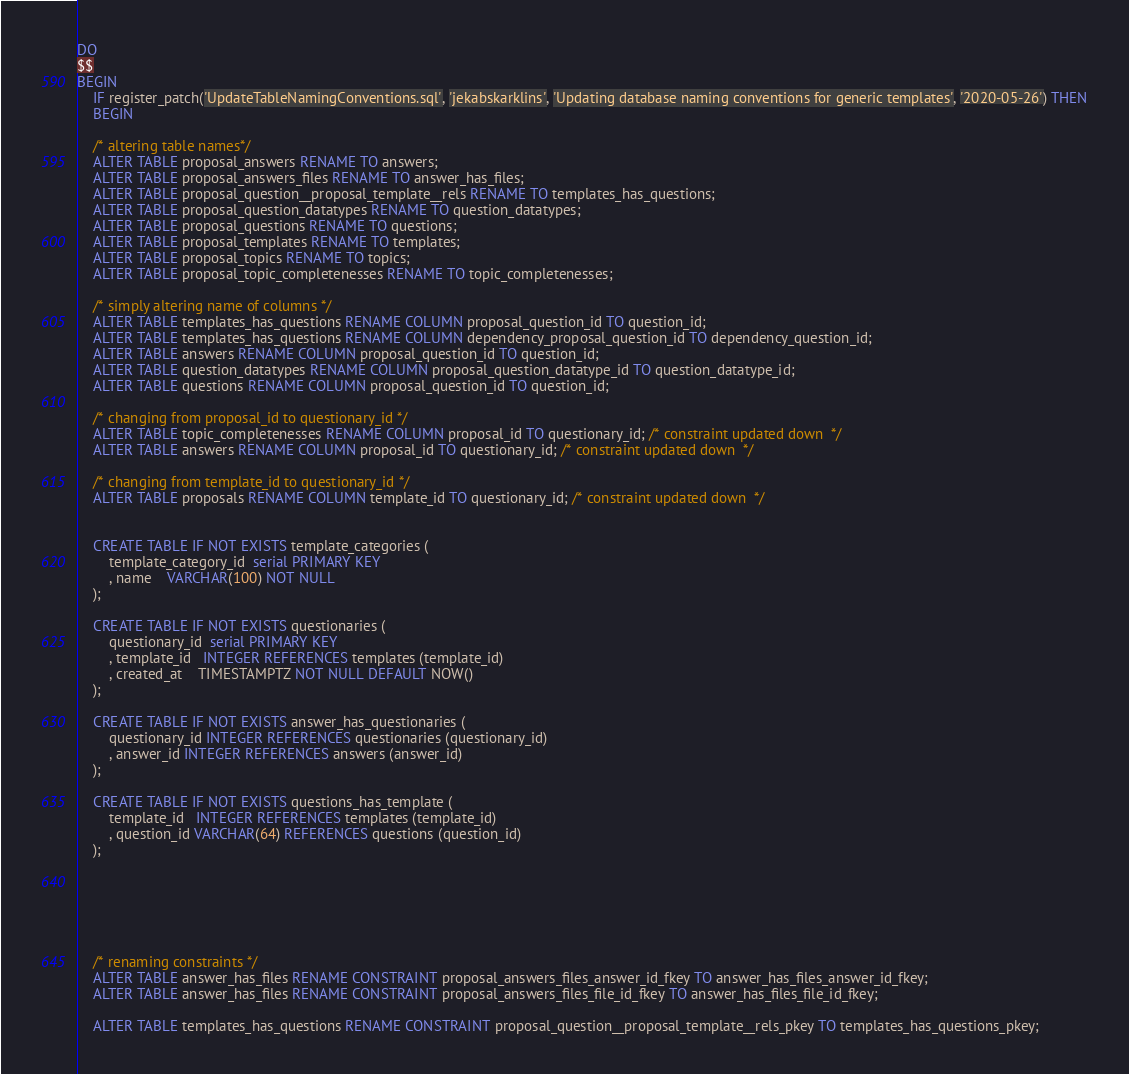Convert code to text. <code><loc_0><loc_0><loc_500><loc_500><_SQL_>DO
$$
BEGIN
	IF register_patch('UpdateTableNamingConventions.sql', 'jekabskarklins', 'Updating database naming conventions for generic templates', '2020-05-26') THEN
	BEGIN

	/* altering table names*/
	ALTER TABLE proposal_answers RENAME TO answers;
	ALTER TABLE proposal_answers_files RENAME TO answer_has_files;
	ALTER TABLE proposal_question__proposal_template__rels RENAME TO templates_has_questions;
	ALTER TABLE proposal_question_datatypes RENAME TO question_datatypes;
	ALTER TABLE proposal_questions RENAME TO questions;
	ALTER TABLE proposal_templates RENAME TO templates;
	ALTER TABLE proposal_topics RENAME TO topics;
	ALTER TABLE proposal_topic_completenesses RENAME TO topic_completenesses;

	/* simply altering name of columns */
	ALTER TABLE templates_has_questions RENAME COLUMN proposal_question_id TO question_id;
	ALTER TABLE templates_has_questions RENAME COLUMN dependency_proposal_question_id TO dependency_question_id;
	ALTER TABLE answers RENAME COLUMN proposal_question_id TO question_id;
	ALTER TABLE question_datatypes RENAME COLUMN proposal_question_datatype_id TO question_datatype_id;
	ALTER TABLE questions RENAME COLUMN proposal_question_id TO question_id;

	/* changing from proposal_id to questionary_id */
	ALTER TABLE topic_completenesses RENAME COLUMN proposal_id TO questionary_id; /* constraint updated down  */
    ALTER TABLE answers RENAME COLUMN proposal_id TO questionary_id; /* constraint updated down  */
	
	/* changing from template_id to questionary_id */
	ALTER TABLE proposals RENAME COLUMN template_id TO questionary_id; /* constraint updated down  */


	CREATE TABLE IF NOT EXISTS template_categories (
		template_category_id  serial PRIMARY KEY
		, name    VARCHAR(100) NOT NULL
	);

	CREATE TABLE IF NOT EXISTS questionaries (
		questionary_id  serial PRIMARY KEY
		, template_id   INTEGER REFERENCES templates (template_id)
		, created_at    TIMESTAMPTZ NOT NULL DEFAULT NOW()
	);

	CREATE TABLE IF NOT EXISTS answer_has_questionaries (
		questionary_id INTEGER REFERENCES questionaries (questionary_id)
		, answer_id INTEGER REFERENCES answers (answer_id)
	);

	CREATE TABLE IF NOT EXISTS questions_has_template (
		template_id   INTEGER REFERENCES templates (template_id)
		, question_id VARCHAR(64) REFERENCES questions (question_id)
	);






	/* renaming constraints */
	ALTER TABLE answer_has_files RENAME CONSTRAINT proposal_answers_files_answer_id_fkey TO answer_has_files_answer_id_fkey;
	ALTER TABLE answer_has_files RENAME CONSTRAINT proposal_answers_files_file_id_fkey TO answer_has_files_file_id_fkey;

	ALTER TABLE templates_has_questions RENAME CONSTRAINT proposal_question__proposal_template__rels_pkey TO templates_has_questions_pkey;</code> 